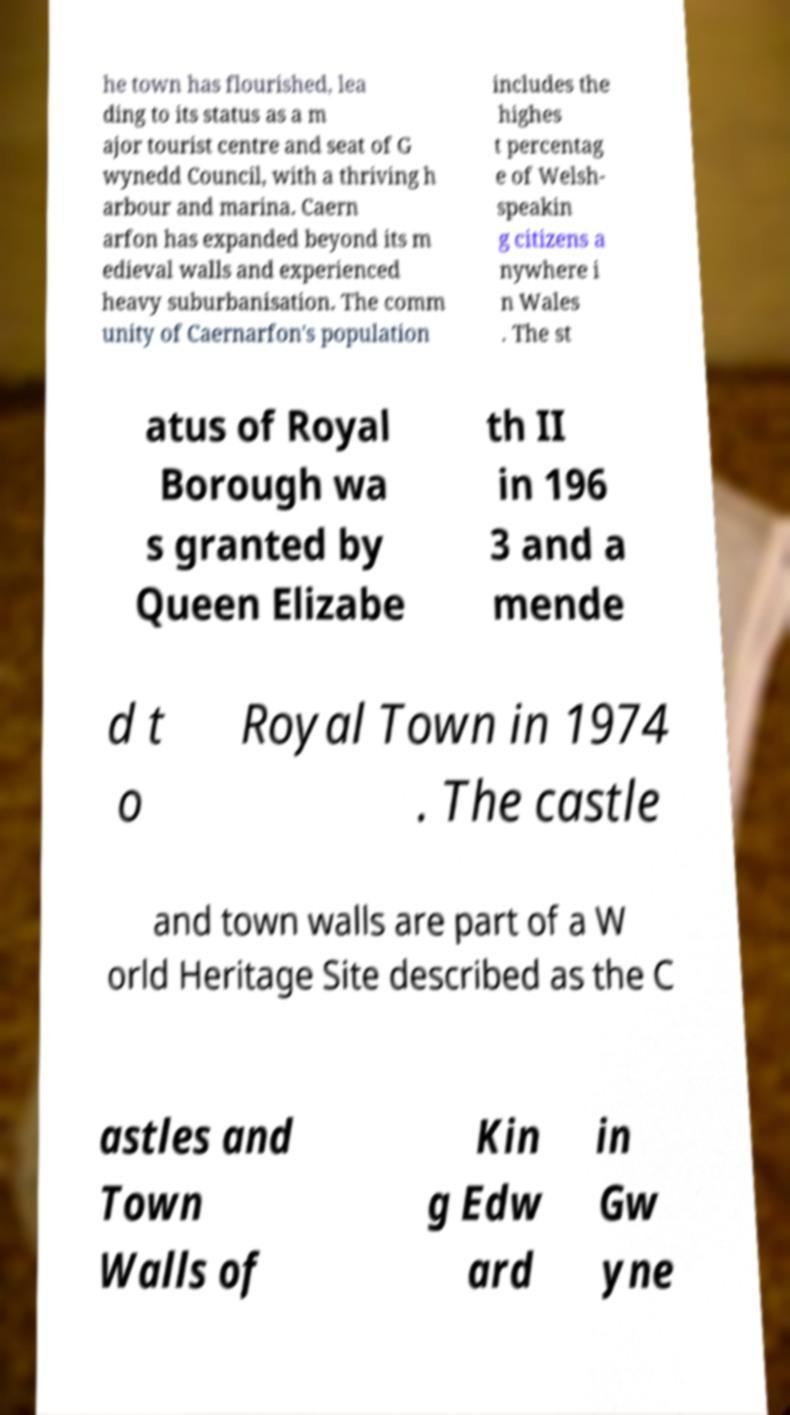Could you assist in decoding the text presented in this image and type it out clearly? he town has flourished, lea ding to its status as a m ajor tourist centre and seat of G wynedd Council, with a thriving h arbour and marina. Caern arfon has expanded beyond its m edieval walls and experienced heavy suburbanisation. The comm unity of Caernarfon's population includes the highes t percentag e of Welsh- speakin g citizens a nywhere i n Wales . The st atus of Royal Borough wa s granted by Queen Elizabe th II in 196 3 and a mende d t o Royal Town in 1974 . The castle and town walls are part of a W orld Heritage Site described as the C astles and Town Walls of Kin g Edw ard in Gw yne 